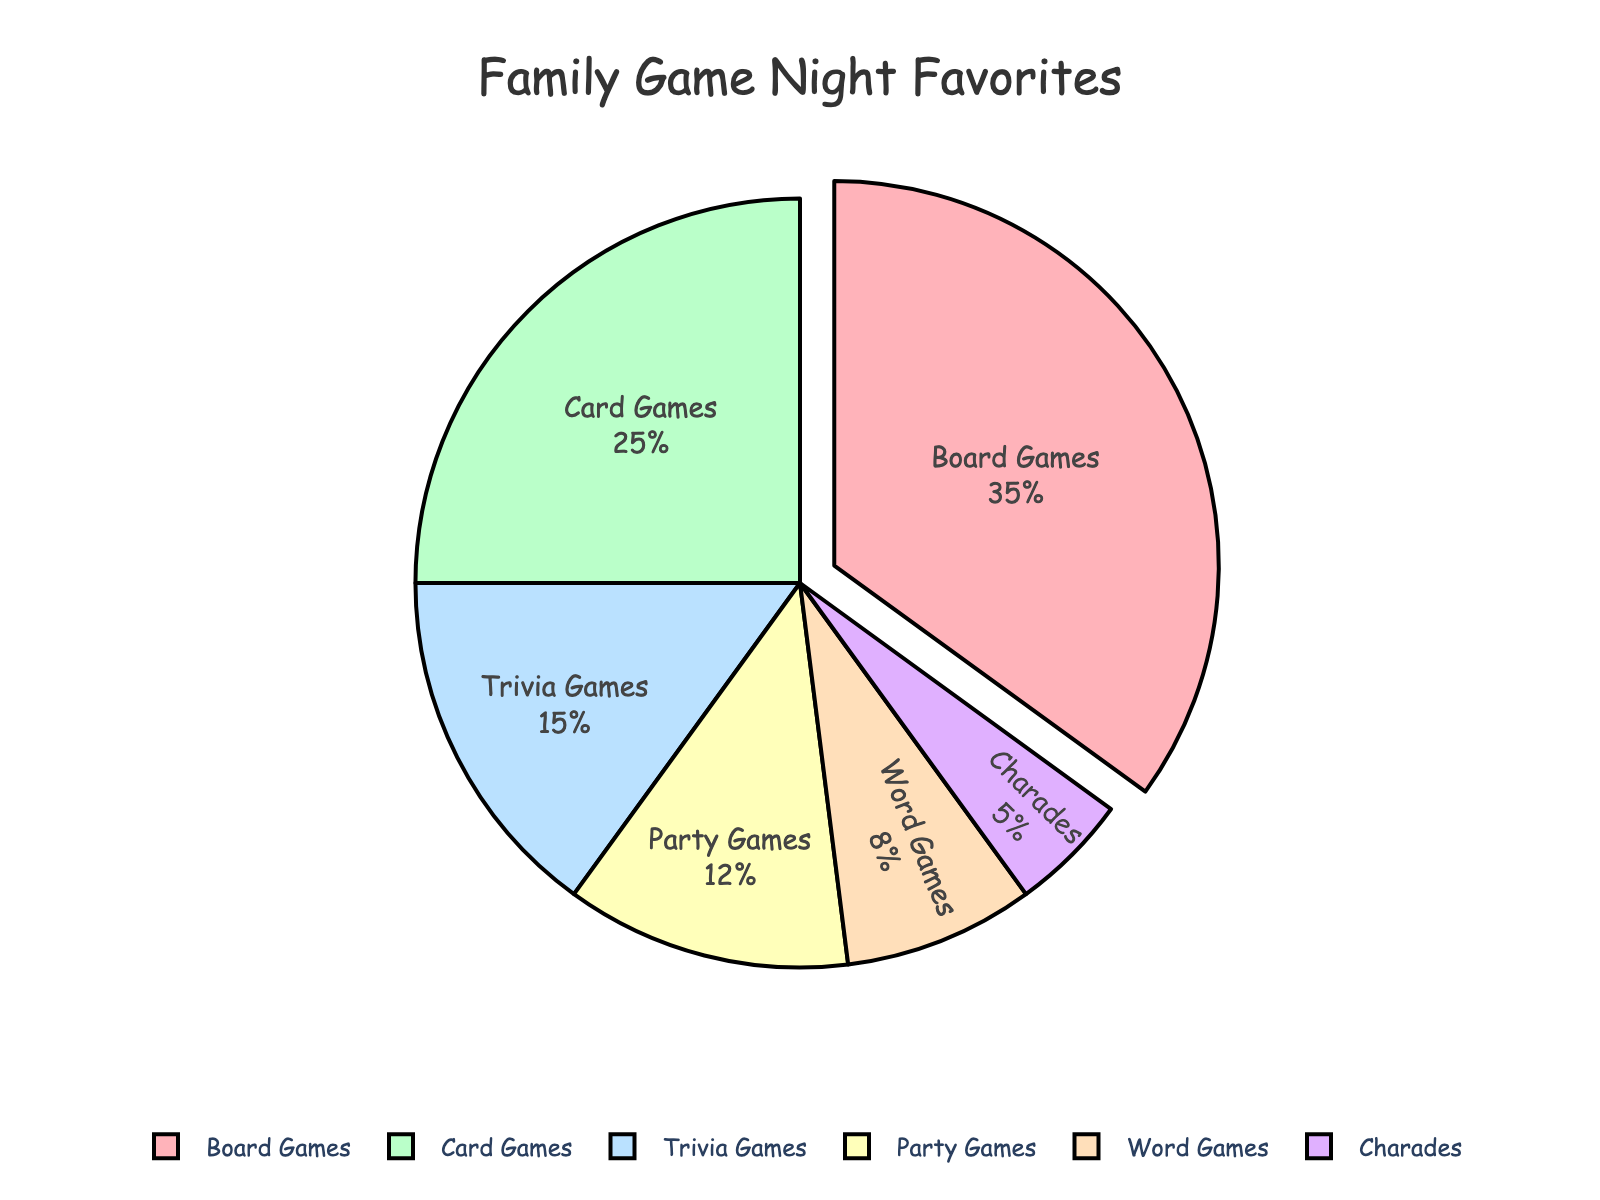What's the most popular genre in family game nights? The figure highlights which genre has the highest percentage by pulling it out slightly from the pie. According to the data, 'Board Games' have the highest percentage.
Answer: Board Games Which genre has the smallest representation in family game nights? By looking at the pie chart, the smallest segment, which represents the least percentage, is 'Charades' with 5%.
Answer: Charades What is the combined percentage of Card Games and Trivia Games? Adding the percentages of Card Games (25%) and Trivia Games (15%) together, we get: 25 + 15 = 40
Answer: 40% How much more popular are Board Games compared to Word Games in percentage? Subtract the percentage of Word Games (8%) from Board Games (35%): 35 - 8 = 27
Answer: 27% Are Trivia Games and Party Games equally popular? By comparing their percentages in the figure, Trivia Games have 15% and Party Games have 12%. They are not equal.
Answer: No Which genre is represented by the blue section of the pie chart? Reviewing the pie chart, the blue section represents 'Trivia Games'.
Answer: Trivia Games Is the genre represented by the yellow section less popular than the genre represented by the green section? In the figure, the yellow section (Party Games) has 12%, and the green section (Card Games) has 25%. Yes, Party Games are less popular.
Answer: Yes What is the total percentage of Word Games and Charades combined? Adding the percentages of Word Games (8%) and Charades (5%) together, we get: 8 + 5 = 13
Answer: 13% Which genre is more popular: Party Games or Word Games? Comparing their percentages in the figure, Party Games have 12% and Word Games have 8%, so Party Games are more popular.
Answer: Party Games What proportion of the family's favorite games are either Board Games or Party Games? Add the percentages of Board Games (35%) and Party Games (12%). The total is: 35 + 12 = 47
Answer: 47% 